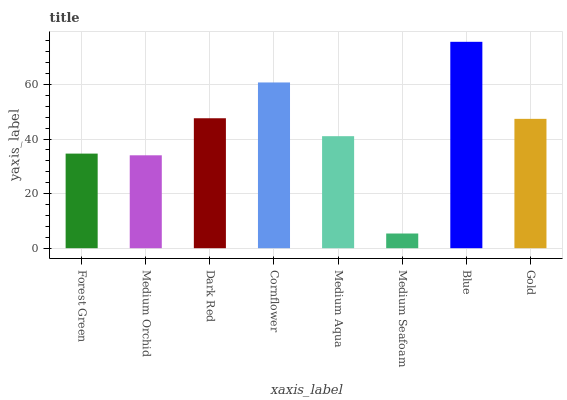Is Medium Orchid the minimum?
Answer yes or no. No. Is Medium Orchid the maximum?
Answer yes or no. No. Is Forest Green greater than Medium Orchid?
Answer yes or no. Yes. Is Medium Orchid less than Forest Green?
Answer yes or no. Yes. Is Medium Orchid greater than Forest Green?
Answer yes or no. No. Is Forest Green less than Medium Orchid?
Answer yes or no. No. Is Gold the high median?
Answer yes or no. Yes. Is Medium Aqua the low median?
Answer yes or no. Yes. Is Cornflower the high median?
Answer yes or no. No. Is Cornflower the low median?
Answer yes or no. No. 